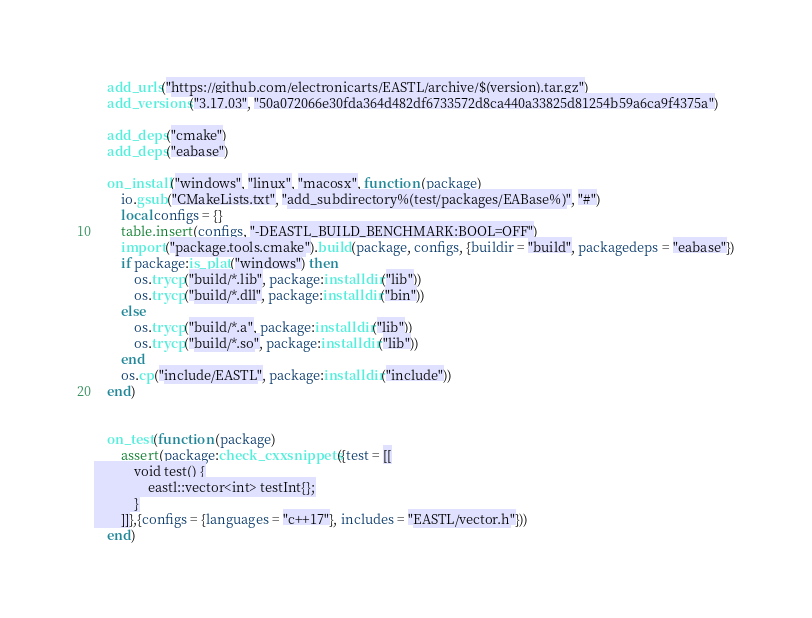<code> <loc_0><loc_0><loc_500><loc_500><_Lua_>    add_urls("https://github.com/electronicarts/EASTL/archive/$(version).tar.gz")
    add_versions("3.17.03", "50a072066e30fda364d482df6733572d8ca440a33825d81254b59a6ca9f4375a")

    add_deps("cmake")
    add_deps("eabase")

    on_install("windows", "linux", "macosx", function (package)
        io.gsub("CMakeLists.txt", "add_subdirectory%(test/packages/EABase%)", "#")
        local configs = {}
        table.insert(configs, "-DEASTL_BUILD_BENCHMARK:BOOL=OFF")
        import("package.tools.cmake").build(package, configs, {buildir = "build", packagedeps = "eabase"})
        if package:is_plat("windows") then
            os.trycp("build/*.lib", package:installdir("lib"))
            os.trycp("build/*.dll", package:installdir("bin"))
        else
            os.trycp("build/*.a", package:installdir("lib"))
            os.trycp("build/*.so", package:installdir("lib"))
        end
        os.cp("include/EASTL", package:installdir("include"))
    end)


    on_test(function (package)
        assert(package:check_cxxsnippets({test = [[
            void test() {
                eastl::vector<int> testInt{};
            }
        ]]},{configs = {languages = "c++17"}, includes = "EASTL/vector.h"}))
    end)</code> 